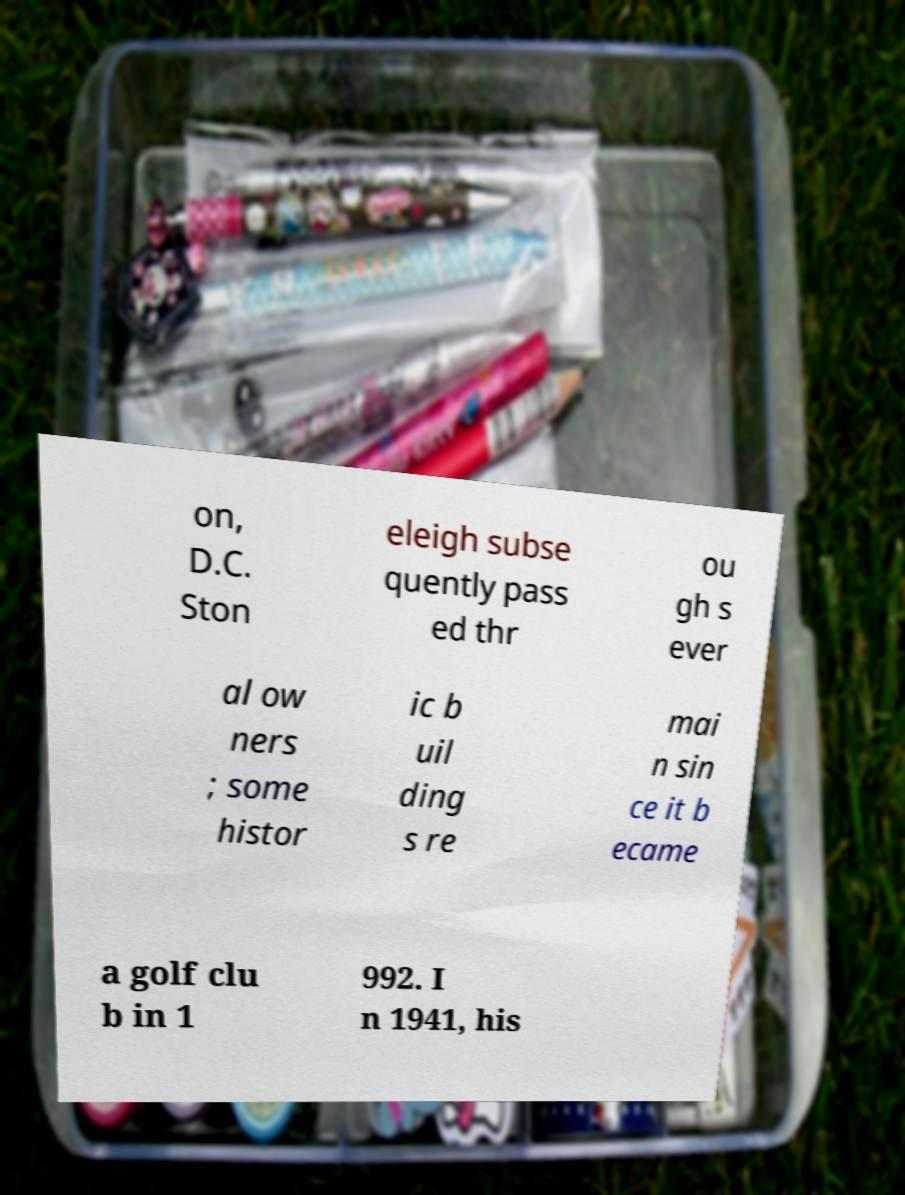I need the written content from this picture converted into text. Can you do that? on, D.C. Ston eleigh subse quently pass ed thr ou gh s ever al ow ners ; some histor ic b uil ding s re mai n sin ce it b ecame a golf clu b in 1 992. I n 1941, his 